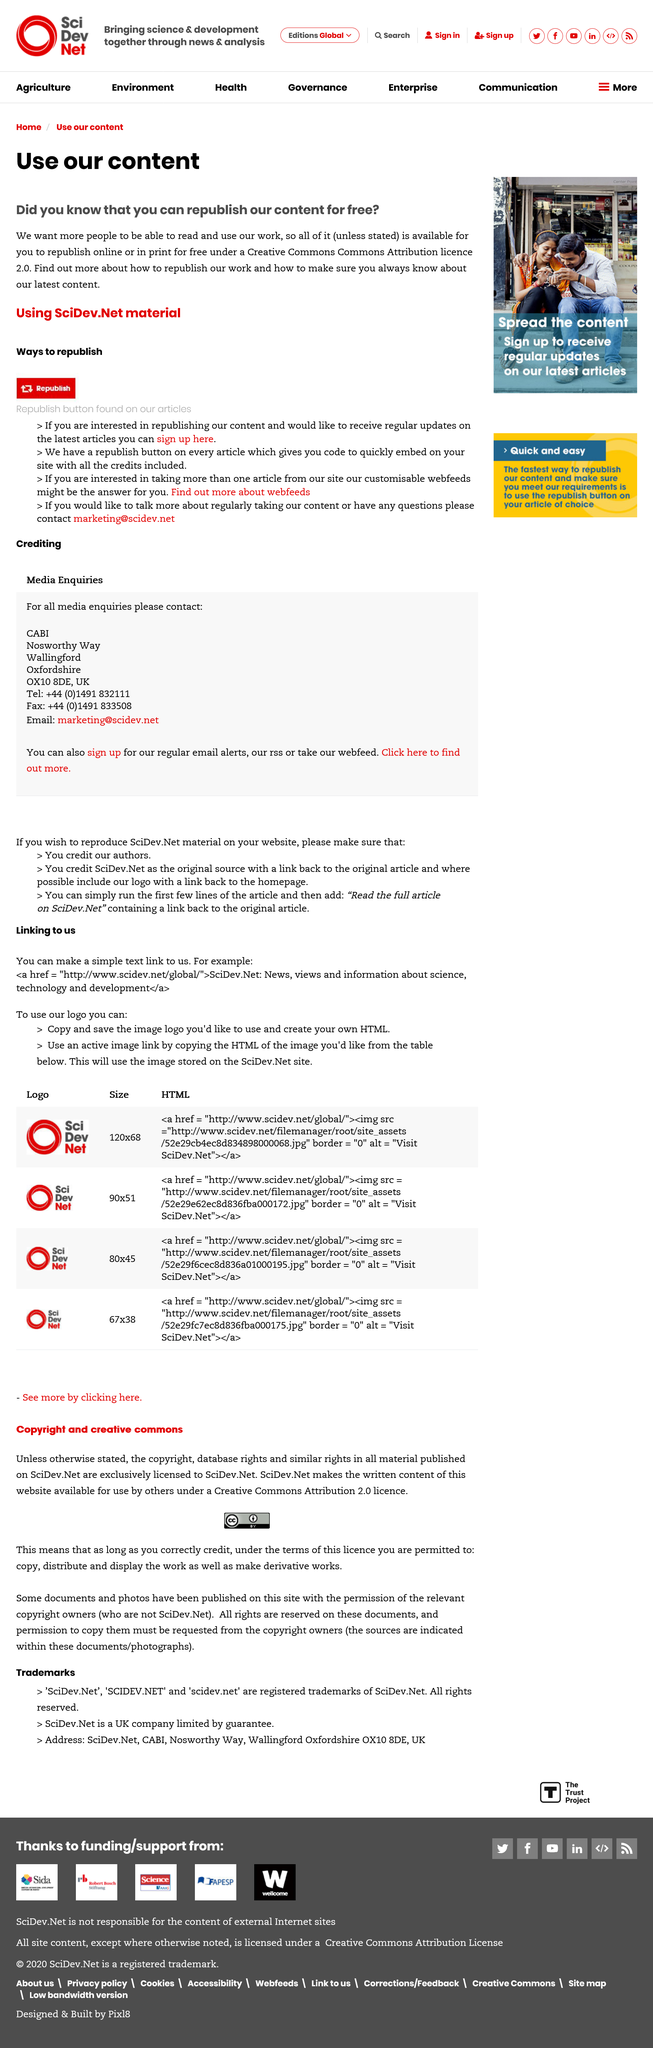Outline some significant characteristics in this image. I hereby confirm that I am willing to republish the content at no cost. You are able to republish the articles under the Creative Commons Attribution license 2.0. 